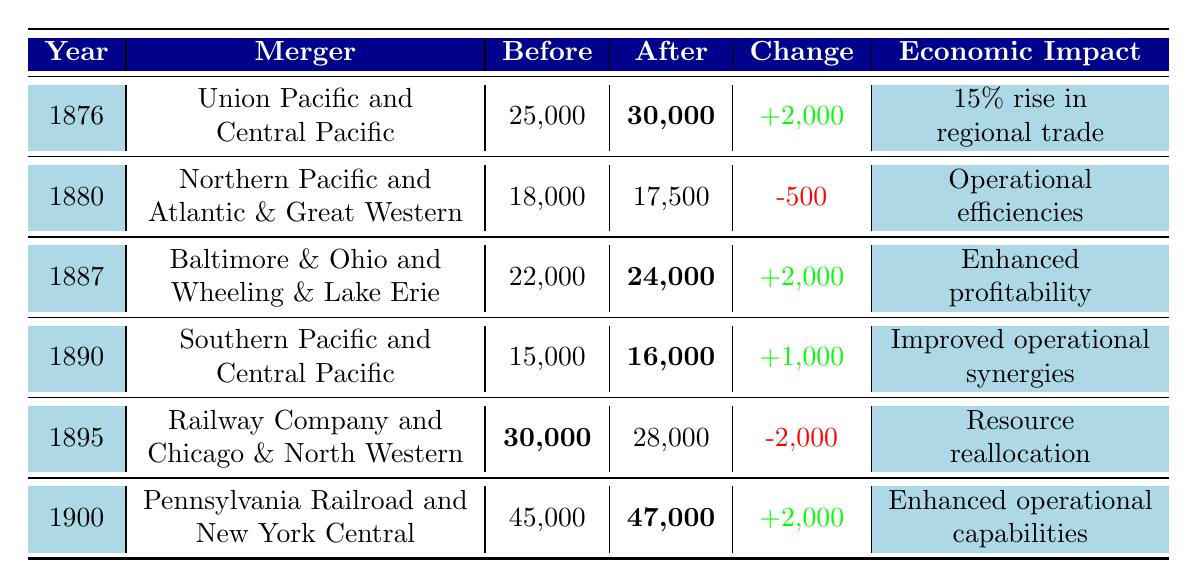What was the employment change in 1880 after the merger of Northern Pacific and Atlantic & Great Western? The table shows that the employment after this merger was 17,500, and before it was 18,000. To find the employment change, subtract the after employment from the before employment: 18,000 - 17,500 = 500. Since the change is negative, the employment decreased by 500.
Answer: -500 Which merger occurred in the year with the highest employment change? By examining the employment change values in the table, the highest change (increased or decreased) is +2,000, which happened in 1876, after the merger of Union Pacific and Central Pacific. Therefore, this is the merger that corresponds to the highest employment change.
Answer: Union Pacific and Central Pacific What was the total employment across all mergers before the year 1900? To find the total employment before 1900, we add the before employment values for each merger before that year: 25,000 + 18,000 + 22,000 + 15,000 + 30,000 = 110,000.
Answer: 110,000 Did the merger of Railway Company and Chicago & North Western lead to an increase in employment? The table shows that this merger resulted in an employment change of -2,000. This indicates a decrease in employment, so the answer is no, it did not lead to an increase.
Answer: No What is the average employment after mergers listed in the table up to the year 1900? The after employment figures for the mergers in the table are 30,000, 17,500, 24,000, 16,000, 28,000, and 47,000. First, sum these values: 30,000 + 17,500 + 24,000 + 16,000 + 28,000 + 47,000 = 162,500. There are 6 data points, so the average is 162,500 / 6 = 27,083.33, which can be rounded to 27,083.
Answer: 27,083 Which merger had a positive economic impact related to regional trade? The merger of Union Pacific and Central Pacific in 1876 had an economic impact describing a "15% rise in regional trade," indicating a positive effect related to trade. Thus, this is the relevant merger.
Answer: Union Pacific and Central Pacific What were the employment trends from 1890 to 1900 based on the table? In 1890, after the merger of Southern Pacific and Central Pacific, the employment increased to 16,000. In 1900, after the merger of Pennsylvania Railroad and New York Central, it increased further to 47,000. This shows a clear trend of increasing employment from 1890 to 1900.
Answer: Increasing Which year saw a decrease in employment after a merger and what was the value? In 1895, after the merger of Railway Company and Chicago & North Western, the employment decreased by 2,000, as indicated by the values in the table.
Answer: 1895, -2000 What is the overall trend in employment changes observed in these rail mergers from 1876 to 1900? The table reflects a mixture of employment changes, with some mergers resulting in increases such as in 1876, 1887, 1890, and 1900, while the mergers in 1880 and 1895 show decreases. Overall, the trend favors increases, especially notable in the late 1890s.
Answer: Mixed, generally increasing 